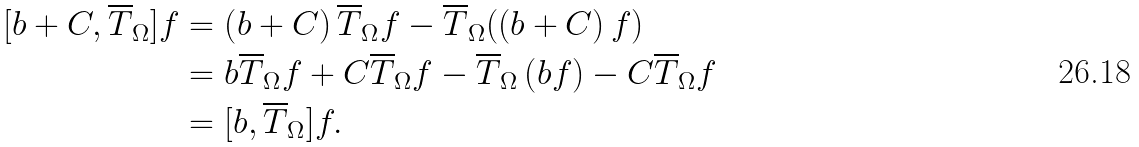<formula> <loc_0><loc_0><loc_500><loc_500>[ b + C , \overline { T } _ { \Omega } ] f & = \left ( b + C \right ) \overline { T } _ { \Omega } f - \overline { T } _ { \Omega } ( \left ( b + C \right ) f ) \\ & = b \overline { T } _ { \Omega } f + C \overline { T } _ { \Omega } f - \overline { T } _ { \Omega } \left ( b f \right ) - C \overline { T } _ { \Omega } f \\ & = [ b , \overline { T } _ { \Omega } ] f .</formula> 